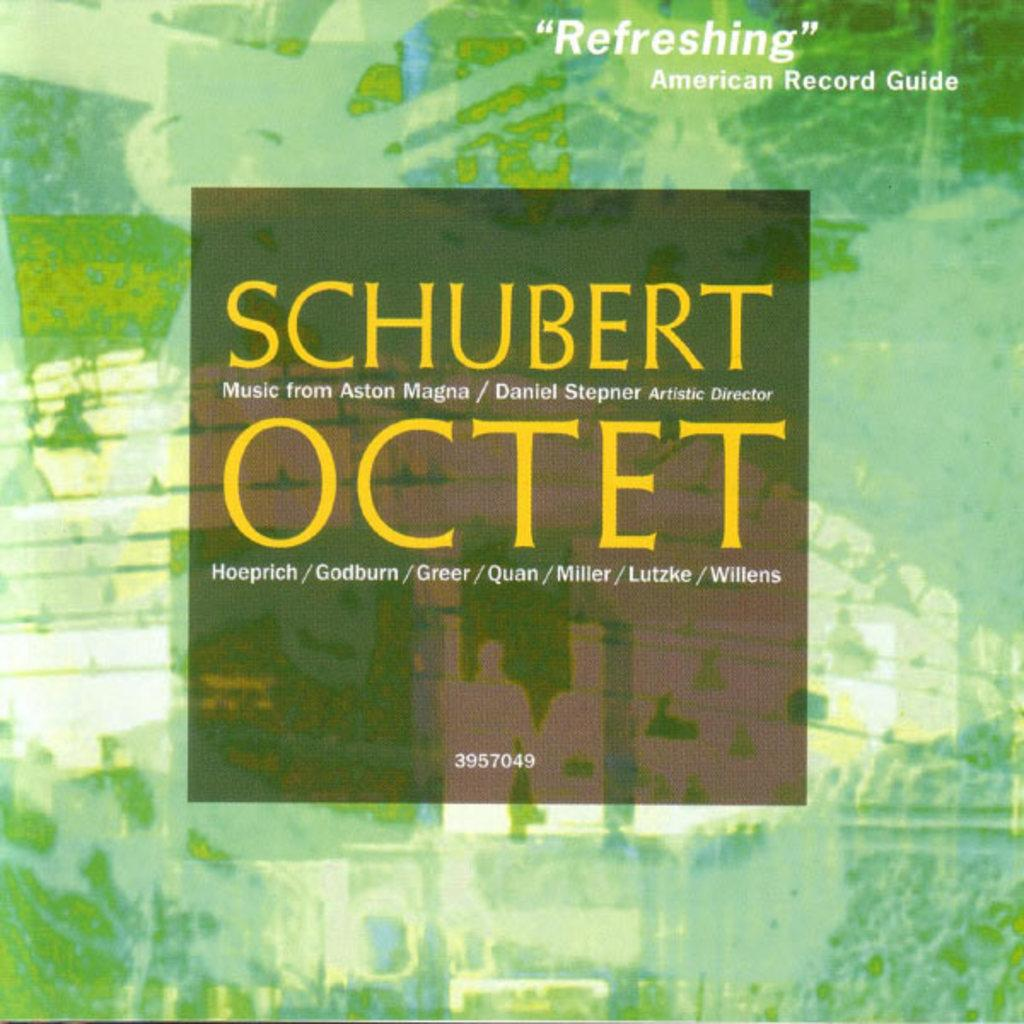<image>
Describe the image concisely. A record of Music from Ashton Magna is called "Refreshing" by the American Record Guide. 